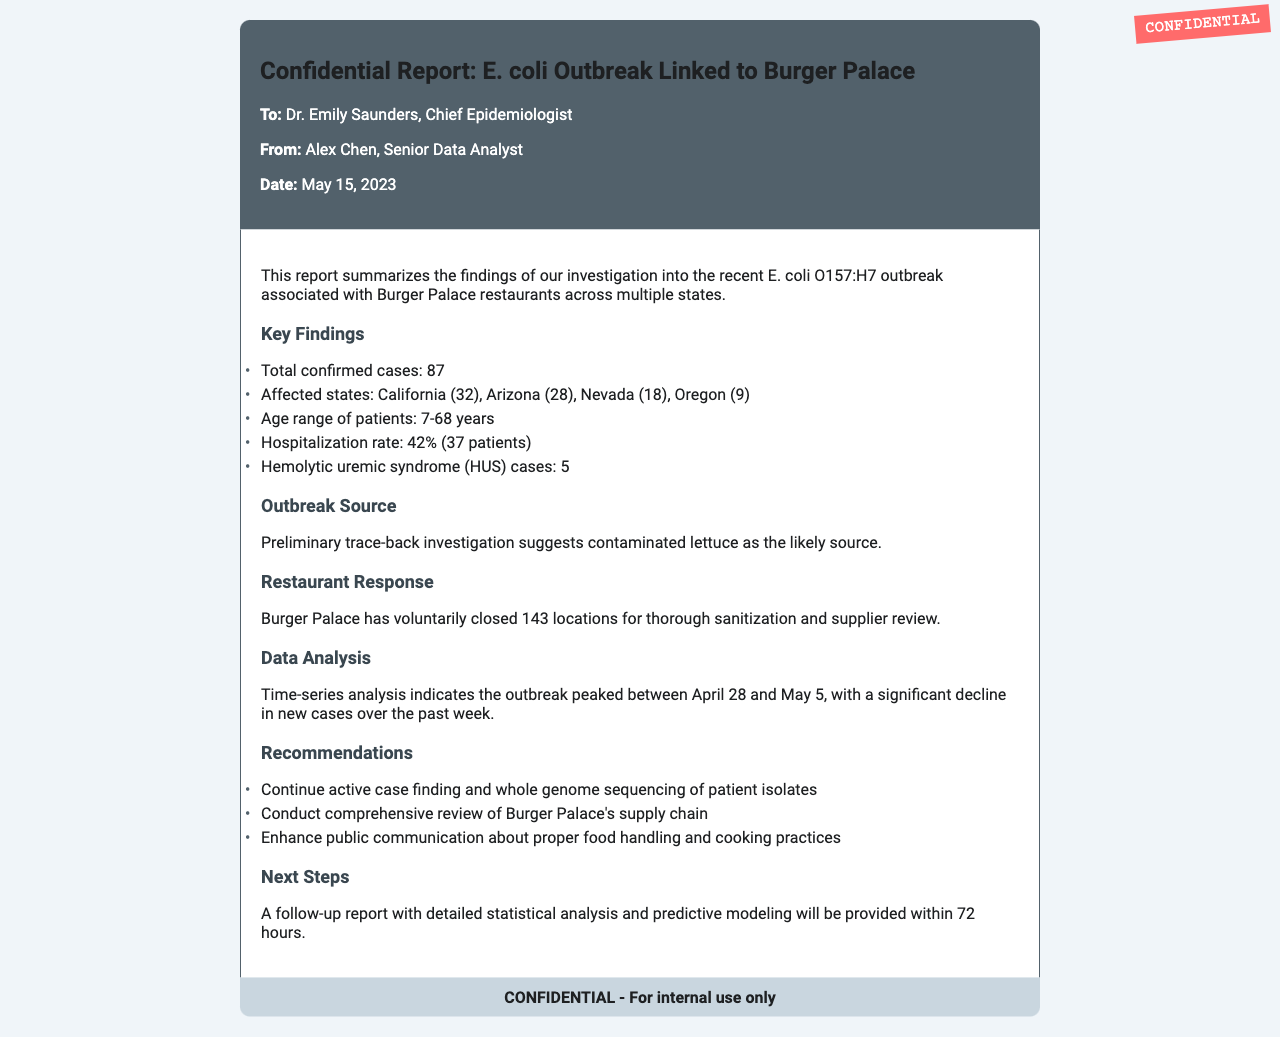What is the total number of confirmed cases? The total number of confirmed cases is stated in the document under Key Findings, which mentions 87 confirmed cases.
Answer: 87 What is the hospitalization rate? The hospitalization rate is specified in the Key Findings section, which indicates a rate of 42% among the confirmed cases.
Answer: 42% How many states are affected by the outbreak? The document lists the affected states under Key Findings, specifying California, Arizona, Nevada, and Oregon.
Answer: 4 What is the age range of patients? This information is found in the Key Findings section, which states the age range of patients is from 7 to 68 years.
Answer: 7-68 years What did the preliminary investigation suggest as the likely outbreak source? The document details under Outbreak Source that contaminated lettuce is considered the likely source of the outbreak.
Answer: Contaminated lettuce How many locations did Burger Palace close? The document indicates under Restaurant Response that Burger Palace closed 143 locations for sanitization.
Answer: 143 When did the outbreak peak? This information is available under Data Analysis, which indicates the outbreak peaked between April 28 and May 5.
Answer: April 28 to May 5 What follows this report within 72 hours? The Next Steps section states that a follow-up report with detailed statistical analysis will be provided within 72 hours.
Answer: Follow-up report Who is the Chief Epidemiologist receiving this report? The report is addressed to Dr. Emily Saunders, who is identified as the Chief Epidemiologist at the top of the document.
Answer: Dr. Emily Saunders 